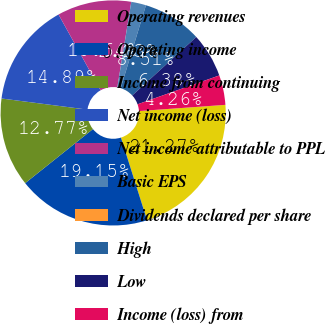Convert chart to OTSL. <chart><loc_0><loc_0><loc_500><loc_500><pie_chart><fcel>Operating revenues<fcel>Operating income<fcel>Income from continuing<fcel>Net income (loss)<fcel>Net income attributable to PPL<fcel>Basic EPS<fcel>Dividends declared per share<fcel>High<fcel>Low<fcel>Income (loss) from<nl><fcel>21.27%<fcel>19.15%<fcel>12.77%<fcel>14.89%<fcel>10.64%<fcel>2.13%<fcel>0.0%<fcel>8.51%<fcel>6.38%<fcel>4.26%<nl></chart> 